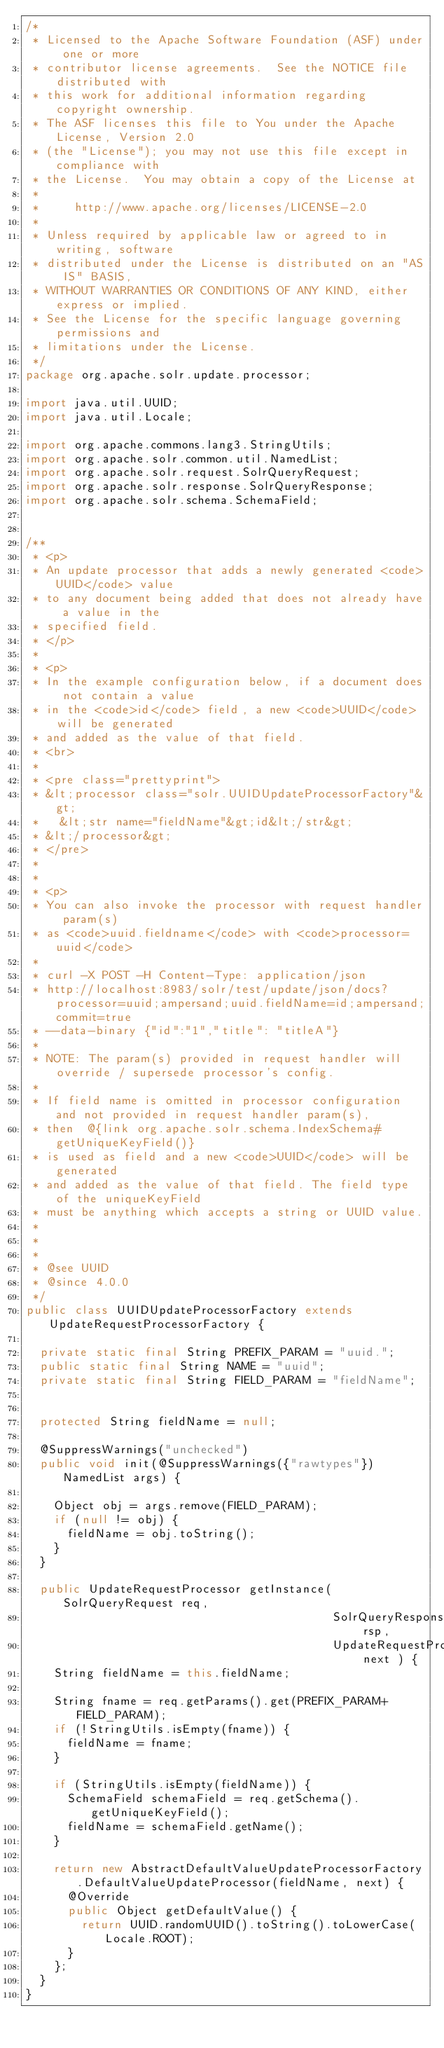Convert code to text. <code><loc_0><loc_0><loc_500><loc_500><_Java_>/*
 * Licensed to the Apache Software Foundation (ASF) under one or more
 * contributor license agreements.  See the NOTICE file distributed with
 * this work for additional information regarding copyright ownership.
 * The ASF licenses this file to You under the Apache License, Version 2.0
 * (the "License"); you may not use this file except in compliance with
 * the License.  You may obtain a copy of the License at
 *
 *     http://www.apache.org/licenses/LICENSE-2.0
 *
 * Unless required by applicable law or agreed to in writing, software
 * distributed under the License is distributed on an "AS IS" BASIS,
 * WITHOUT WARRANTIES OR CONDITIONS OF ANY KIND, either express or implied.
 * See the License for the specific language governing permissions and
 * limitations under the License.
 */
package org.apache.solr.update.processor;

import java.util.UUID;
import java.util.Locale;

import org.apache.commons.lang3.StringUtils;
import org.apache.solr.common.util.NamedList;
import org.apache.solr.request.SolrQueryRequest;
import org.apache.solr.response.SolrQueryResponse;
import org.apache.solr.schema.SchemaField;


/**
 * <p>
 * An update processor that adds a newly generated <code>UUID</code> value
 * to any document being added that does not already have a value in the
 * specified field.
 * </p>
 *
 * <p>
 * In the example configuration below, if a document does not contain a value
 * in the <code>id</code> field, a new <code>UUID</code> will be generated
 * and added as the value of that field.
 * <br>
 *
 * <pre class="prettyprint">
 * &lt;processor class="solr.UUIDUpdateProcessorFactory"&gt;
 *   &lt;str name="fieldName"&gt;id&lt;/str&gt;
 * &lt;/processor&gt;
 * </pre>
 *
 *
 * <p>
 * You can also invoke the processor with request handler param(s)
 * as <code>uuid.fieldname</code> with <code>processor=uuid</code>
 *
 * curl -X POST -H Content-Type: application/json
 * http://localhost:8983/solr/test/update/json/docs?processor=uuid;ampersand;uuid.fieldName=id;ampersand;commit=true
 * --data-binary {"id":"1","title": "titleA"}
 *
 * NOTE: The param(s) provided in request handler will override / supersede processor's config.
 *
 * If field name is omitted in processor configuration and not provided in request handler param(s),
 * then  @{link org.apache.solr.schema.IndexSchema#getUniqueKeyField()}
 * is used as field and a new <code>UUID</code> will be generated
 * and added as the value of that field. The field type of the uniqueKeyField
 * must be anything which accepts a string or UUID value.
 *
 *
 *
 * @see UUID
 * @since 4.0.0
 */
public class UUIDUpdateProcessorFactory extends UpdateRequestProcessorFactory {

  private static final String PREFIX_PARAM = "uuid.";
  public static final String NAME = "uuid";
  private static final String FIELD_PARAM = "fieldName";


  protected String fieldName = null;

  @SuppressWarnings("unchecked")
  public void init(@SuppressWarnings({"rawtypes"})NamedList args) {

    Object obj = args.remove(FIELD_PARAM);
    if (null != obj) {
      fieldName = obj.toString();
    }
  }

  public UpdateRequestProcessor getInstance(SolrQueryRequest req,
                                            SolrQueryResponse rsp,
                                            UpdateRequestProcessor next ) {
    String fieldName = this.fieldName;

    String fname = req.getParams().get(PREFIX_PARAM+FIELD_PARAM);
    if (!StringUtils.isEmpty(fname)) {
      fieldName = fname;
    }

    if (StringUtils.isEmpty(fieldName)) {
      SchemaField schemaField = req.getSchema().getUniqueKeyField();
      fieldName = schemaField.getName();
    }

    return new AbstractDefaultValueUpdateProcessorFactory.DefaultValueUpdateProcessor(fieldName, next) {
      @Override
      public Object getDefaultValue() {
        return UUID.randomUUID().toString().toLowerCase(Locale.ROOT);
      }
    };
  }
}



</code> 